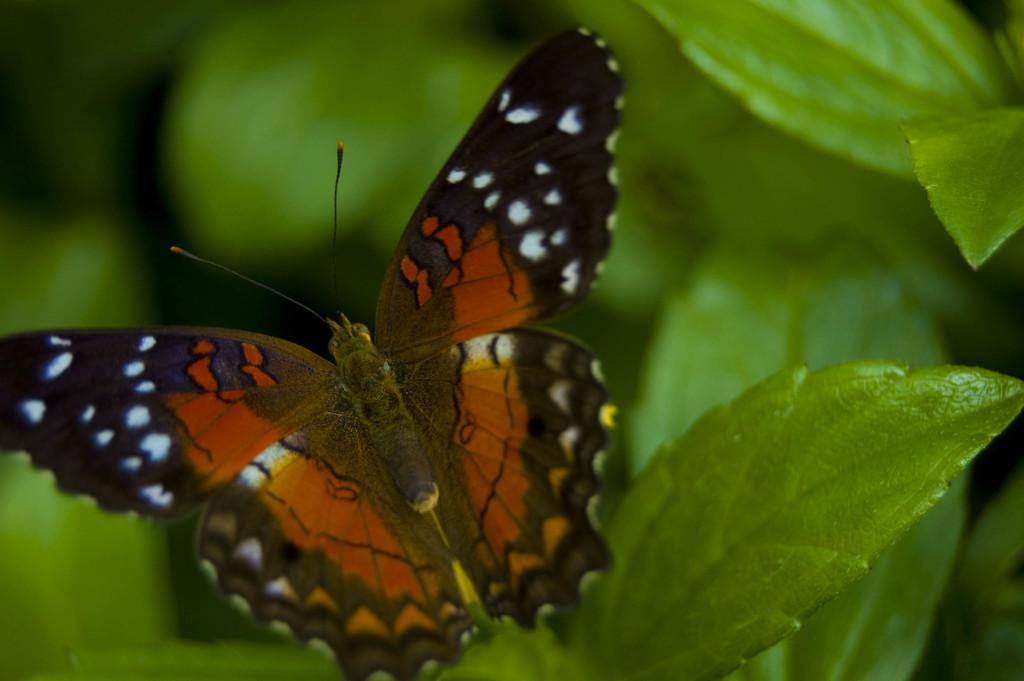What is the main subject in the foreground of the image? There is a butterfly in the foreground of the image. Where is the butterfly located? The butterfly is on a leaf. Can you describe the background of the image? The background of the image is blurred. How does the beggar interact with the butterfly in the image? There is no beggar present in the image, so there is no interaction between a beggar and the butterfly. 